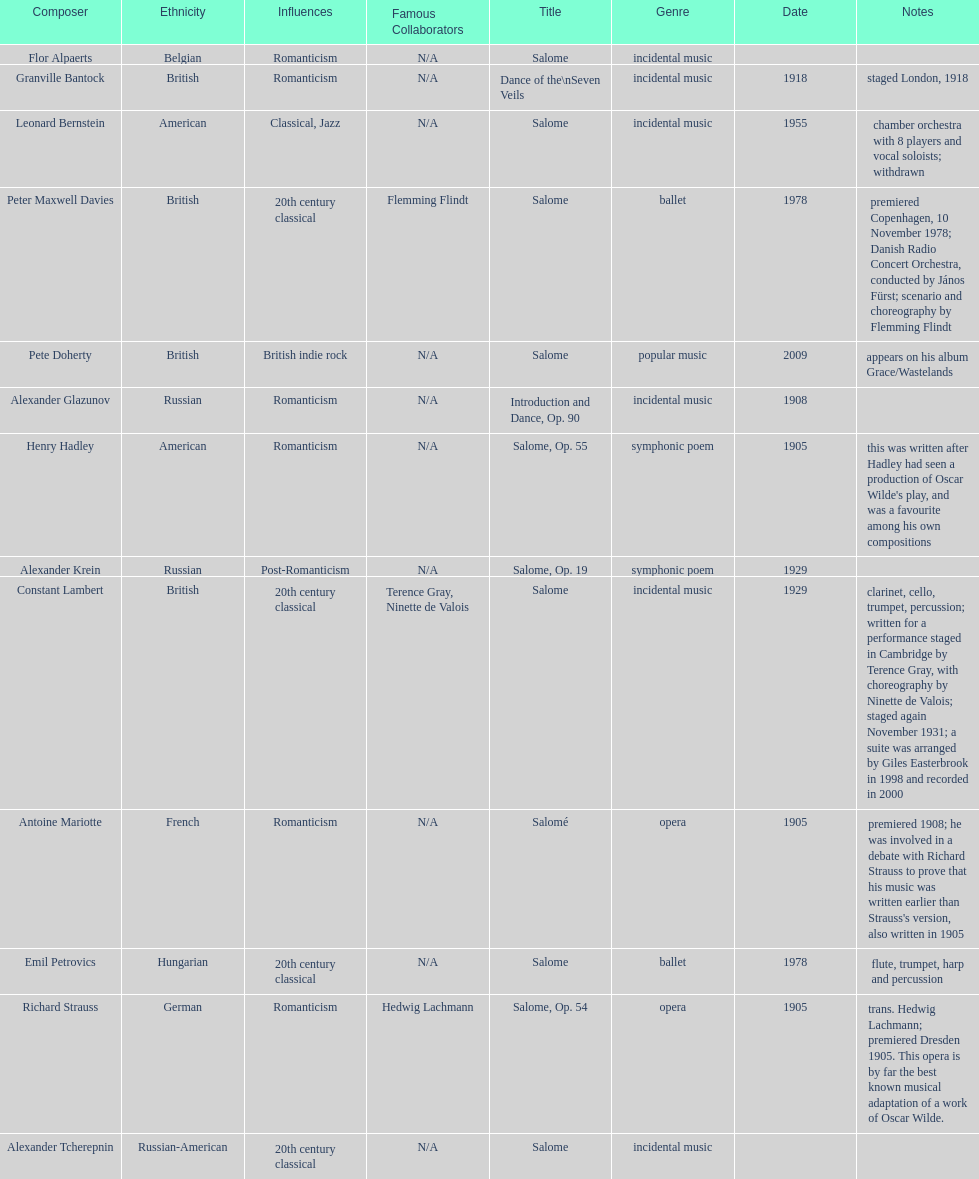How many are symphonic poems? 2. 